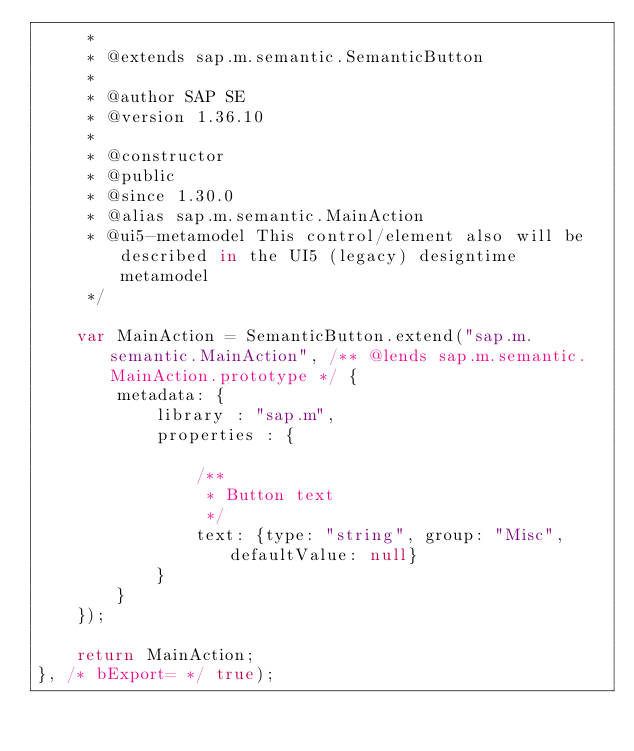<code> <loc_0><loc_0><loc_500><loc_500><_JavaScript_>	 *
	 * @extends sap.m.semantic.SemanticButton
	 *
	 * @author SAP SE
	 * @version 1.36.10
	 *
	 * @constructor
	 * @public
	 * @since 1.30.0
	 * @alias sap.m.semantic.MainAction
	 * @ui5-metamodel This control/element also will be described in the UI5 (legacy) designtime metamodel
	 */

	var MainAction = SemanticButton.extend("sap.m.semantic.MainAction", /** @lends sap.m.semantic.MainAction.prototype */ {
		metadata: {
			library : "sap.m",
			properties : {

				/**
				 * Button text
				 */
				text: {type: "string", group: "Misc", defaultValue: null}
			}
		}
	});

	return MainAction;
}, /* bExport= */ true);
</code> 